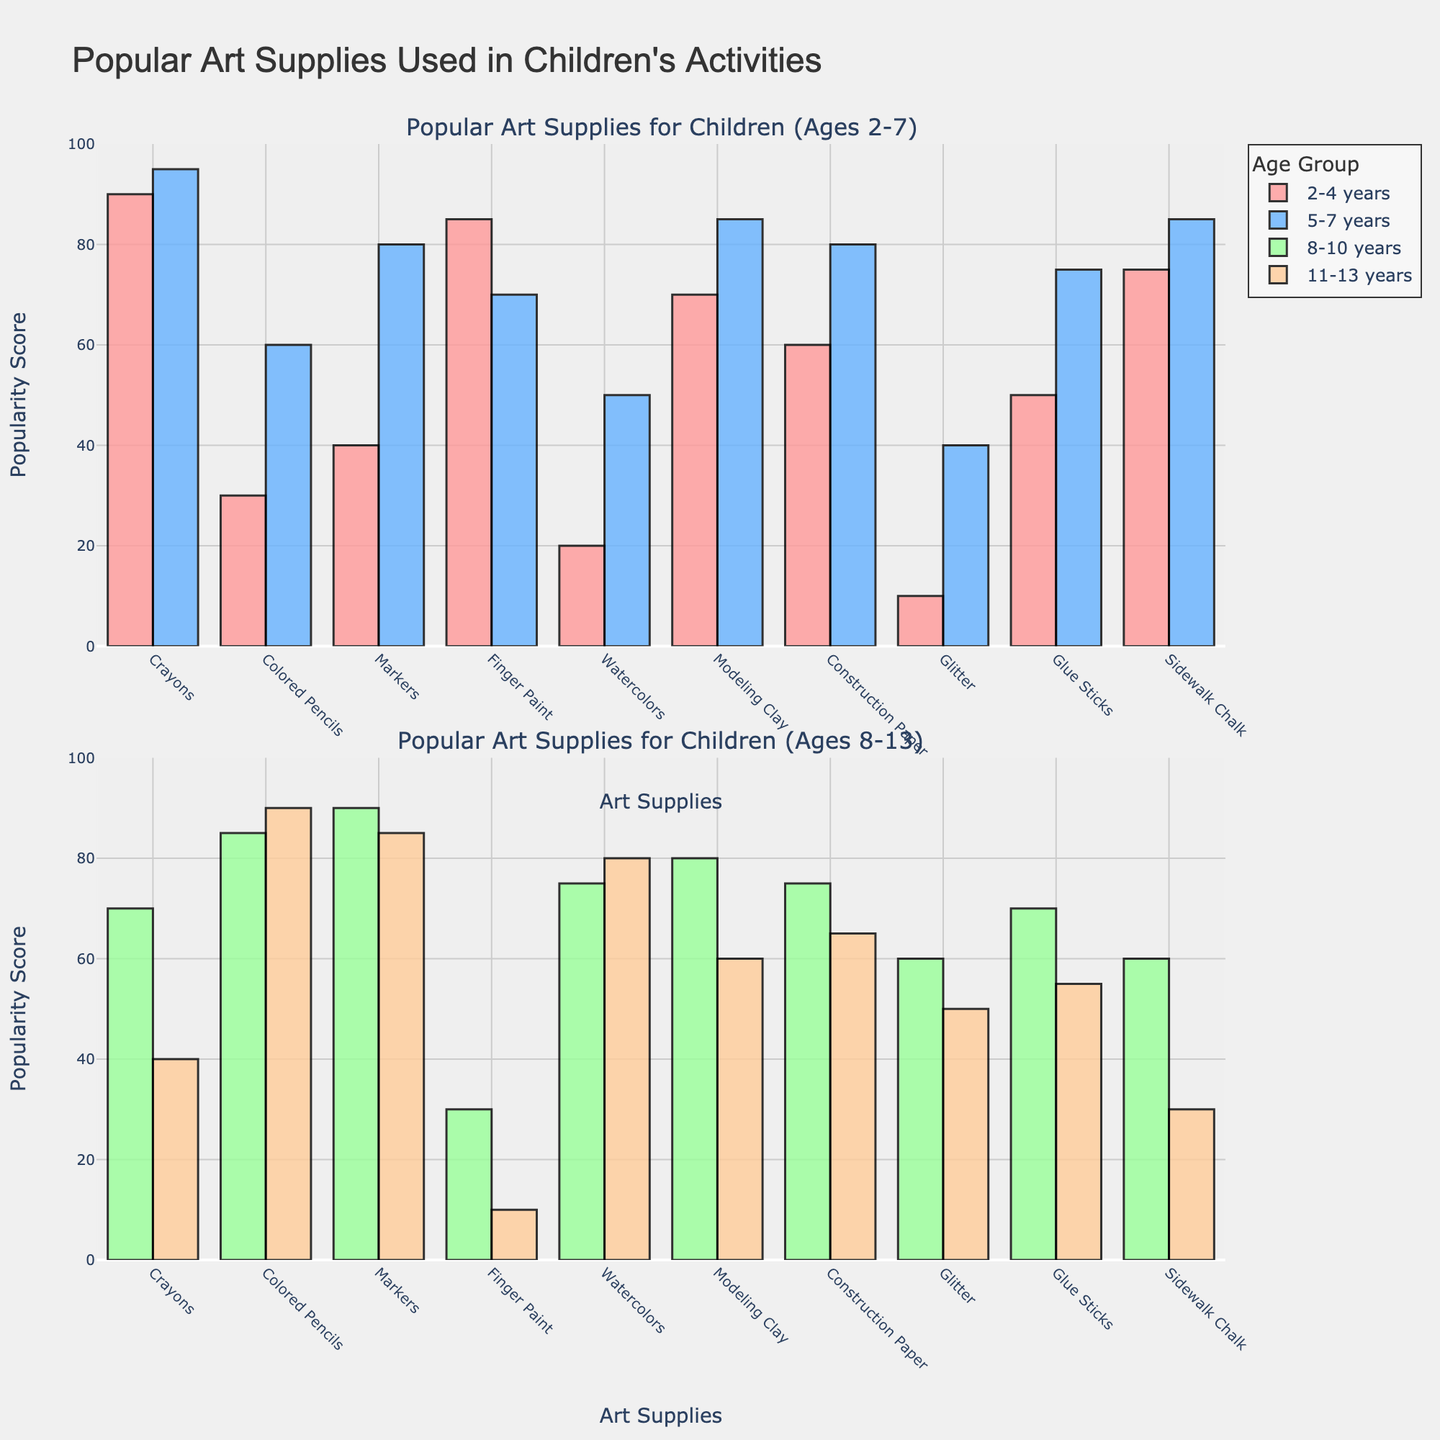What art supply is most popular among 2-4-year-olds? By examining the bar heights for the 2-4 years age group, the bar for Crayons is the tallest at 90, indicating it is the most popular.
Answer: Crayons Which age group has the highest popularity score for Colored Pencils? In the subplot, the tallest bar for Colored Pencils corresponds to the age group 11-13 years with a value of 90.
Answer: 11-13 years How does the popularity of Finger Paint compare between the age groups 2-4 years and 8-10 years? By observing the bars for Finger Paint, the value for the 2-4 years age group is 85, while for the 8-10 years age group, it is 30. The value for 2-4 years is significantly higher.
Answer: 2-4 years Which art supply has the lowest popularity score among 5-7-year-olds? In the 5-7 years age group, Glitter has the lowest score of 40, as indicated by the shortest bar in this group's plot.
Answer: Glitter What is the combined popularity score of Glue Sticks for all age groups? Summing up the popularity scores of Glue Sticks from the bar heights: 50 (2-4 years) + 75 (5-7 years) + 70 (8-10 years) + 55 (11-13 years) = 250.
Answer: 250 Which age group has the most balanced scores for all art supplies? By visual inspection, the 8-10 years age group shows relatively even bar heights for most art supplies, indicating a more balanced popularity.
Answer: 8-10 years How does the usage of Sidewalk Chalk among 2-4-year-olds and 11-13-year-olds compare? The bar height for Sidewalk Chalk in the 2-4 years age group is 75, while for the 11-13 years age group it is 30, indicating it is more popular among the younger age group.
Answer: More popular among 2-4 years What is the average popularity score for Crayons across all age groups? Calculating the average: (90 + 95 + 70 + 40) / 4 = 73.75.
Answer: 73.75 Which art supply's popularity increases with age and then decreases beyond 10 years? Observing the trends, Colored Pencils show this pattern, with scores of 30 (2-4 years), 60 (5-7 years), 85 (8-10 years), and 90 (11-13 years).
Answer: Colored Pencils Compare the popularity of Modeling Clay and Construction Paper for the 5-7 years age group. Which one is higher? For the 5-7 years age group, the bar for Modeling Clay is 85 and the bar for Construction Paper is 80, thus Modeling Clay is slightly higher.
Answer: Modeling Clay 